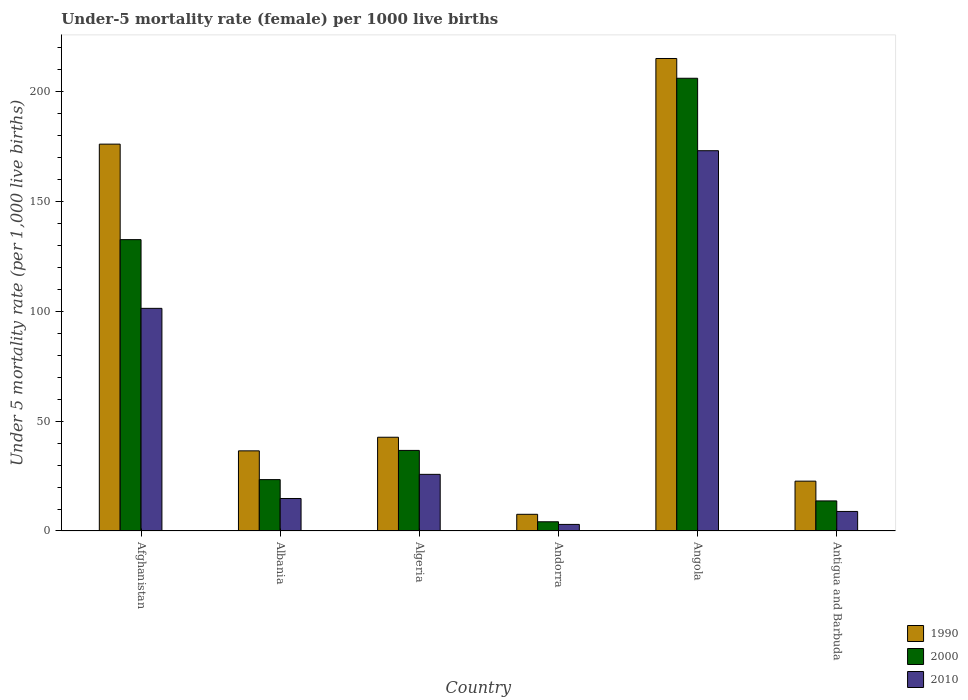How many groups of bars are there?
Keep it short and to the point. 6. Are the number of bars per tick equal to the number of legend labels?
Provide a short and direct response. Yes. Are the number of bars on each tick of the X-axis equal?
Your answer should be very brief. Yes. How many bars are there on the 4th tick from the left?
Ensure brevity in your answer.  3. How many bars are there on the 3rd tick from the right?
Your answer should be very brief. 3. What is the label of the 4th group of bars from the left?
Make the answer very short. Andorra. In how many cases, is the number of bars for a given country not equal to the number of legend labels?
Offer a very short reply. 0. What is the under-five mortality rate in 1990 in Angola?
Provide a short and direct response. 215.2. Across all countries, what is the maximum under-five mortality rate in 2010?
Provide a short and direct response. 173.2. In which country was the under-five mortality rate in 2010 maximum?
Make the answer very short. Angola. In which country was the under-five mortality rate in 2000 minimum?
Provide a short and direct response. Andorra. What is the total under-five mortality rate in 1990 in the graph?
Ensure brevity in your answer.  500.9. What is the difference between the under-five mortality rate in 1990 in Angola and that in Antigua and Barbuda?
Offer a very short reply. 192.5. What is the difference between the under-five mortality rate in 1990 in Algeria and the under-five mortality rate in 2010 in Albania?
Offer a terse response. 27.9. What is the average under-five mortality rate in 1990 per country?
Offer a very short reply. 83.48. What is the difference between the under-five mortality rate of/in 2010 and under-five mortality rate of/in 1990 in Albania?
Ensure brevity in your answer.  -21.7. What is the ratio of the under-five mortality rate in 2000 in Albania to that in Angola?
Your answer should be very brief. 0.11. What is the difference between the highest and the second highest under-five mortality rate in 2010?
Provide a succinct answer. -75.6. What is the difference between the highest and the lowest under-five mortality rate in 2000?
Ensure brevity in your answer.  202. Does the graph contain any zero values?
Make the answer very short. No. Where does the legend appear in the graph?
Ensure brevity in your answer.  Bottom right. How are the legend labels stacked?
Your answer should be very brief. Vertical. What is the title of the graph?
Make the answer very short. Under-5 mortality rate (female) per 1000 live births. Does "2011" appear as one of the legend labels in the graph?
Your answer should be compact. No. What is the label or title of the Y-axis?
Your answer should be compact. Under 5 mortality rate (per 1,0 live births). What is the Under 5 mortality rate (per 1,000 live births) of 1990 in Afghanistan?
Your answer should be very brief. 176.2. What is the Under 5 mortality rate (per 1,000 live births) in 2000 in Afghanistan?
Keep it short and to the point. 132.7. What is the Under 5 mortality rate (per 1,000 live births) in 2010 in Afghanistan?
Keep it short and to the point. 101.4. What is the Under 5 mortality rate (per 1,000 live births) of 1990 in Albania?
Keep it short and to the point. 36.5. What is the Under 5 mortality rate (per 1,000 live births) in 2000 in Albania?
Make the answer very short. 23.4. What is the Under 5 mortality rate (per 1,000 live births) of 1990 in Algeria?
Your answer should be compact. 42.7. What is the Under 5 mortality rate (per 1,000 live births) of 2000 in Algeria?
Provide a short and direct response. 36.7. What is the Under 5 mortality rate (per 1,000 live births) of 2010 in Algeria?
Provide a short and direct response. 25.8. What is the Under 5 mortality rate (per 1,000 live births) of 1990 in Andorra?
Provide a succinct answer. 7.6. What is the Under 5 mortality rate (per 1,000 live births) in 1990 in Angola?
Keep it short and to the point. 215.2. What is the Under 5 mortality rate (per 1,000 live births) in 2000 in Angola?
Make the answer very short. 206.2. What is the Under 5 mortality rate (per 1,000 live births) of 2010 in Angola?
Give a very brief answer. 173.2. What is the Under 5 mortality rate (per 1,000 live births) of 1990 in Antigua and Barbuda?
Provide a succinct answer. 22.7. What is the Under 5 mortality rate (per 1,000 live births) in 2000 in Antigua and Barbuda?
Offer a terse response. 13.7. What is the Under 5 mortality rate (per 1,000 live births) of 2010 in Antigua and Barbuda?
Your response must be concise. 8.9. Across all countries, what is the maximum Under 5 mortality rate (per 1,000 live births) in 1990?
Your response must be concise. 215.2. Across all countries, what is the maximum Under 5 mortality rate (per 1,000 live births) of 2000?
Offer a very short reply. 206.2. Across all countries, what is the maximum Under 5 mortality rate (per 1,000 live births) of 2010?
Your answer should be compact. 173.2. What is the total Under 5 mortality rate (per 1,000 live births) of 1990 in the graph?
Offer a very short reply. 500.9. What is the total Under 5 mortality rate (per 1,000 live births) in 2000 in the graph?
Offer a very short reply. 416.9. What is the total Under 5 mortality rate (per 1,000 live births) of 2010 in the graph?
Your response must be concise. 327.1. What is the difference between the Under 5 mortality rate (per 1,000 live births) of 1990 in Afghanistan and that in Albania?
Your answer should be compact. 139.7. What is the difference between the Under 5 mortality rate (per 1,000 live births) of 2000 in Afghanistan and that in Albania?
Offer a very short reply. 109.3. What is the difference between the Under 5 mortality rate (per 1,000 live births) in 2010 in Afghanistan and that in Albania?
Your answer should be very brief. 86.6. What is the difference between the Under 5 mortality rate (per 1,000 live births) of 1990 in Afghanistan and that in Algeria?
Keep it short and to the point. 133.5. What is the difference between the Under 5 mortality rate (per 1,000 live births) in 2000 in Afghanistan and that in Algeria?
Ensure brevity in your answer.  96. What is the difference between the Under 5 mortality rate (per 1,000 live births) of 2010 in Afghanistan and that in Algeria?
Keep it short and to the point. 75.6. What is the difference between the Under 5 mortality rate (per 1,000 live births) of 1990 in Afghanistan and that in Andorra?
Your response must be concise. 168.6. What is the difference between the Under 5 mortality rate (per 1,000 live births) of 2000 in Afghanistan and that in Andorra?
Give a very brief answer. 128.5. What is the difference between the Under 5 mortality rate (per 1,000 live births) in 2010 in Afghanistan and that in Andorra?
Offer a very short reply. 98.4. What is the difference between the Under 5 mortality rate (per 1,000 live births) of 1990 in Afghanistan and that in Angola?
Offer a very short reply. -39. What is the difference between the Under 5 mortality rate (per 1,000 live births) of 2000 in Afghanistan and that in Angola?
Offer a very short reply. -73.5. What is the difference between the Under 5 mortality rate (per 1,000 live births) in 2010 in Afghanistan and that in Angola?
Offer a very short reply. -71.8. What is the difference between the Under 5 mortality rate (per 1,000 live births) in 1990 in Afghanistan and that in Antigua and Barbuda?
Make the answer very short. 153.5. What is the difference between the Under 5 mortality rate (per 1,000 live births) in 2000 in Afghanistan and that in Antigua and Barbuda?
Provide a succinct answer. 119. What is the difference between the Under 5 mortality rate (per 1,000 live births) of 2010 in Afghanistan and that in Antigua and Barbuda?
Provide a short and direct response. 92.5. What is the difference between the Under 5 mortality rate (per 1,000 live births) of 2000 in Albania and that in Algeria?
Offer a very short reply. -13.3. What is the difference between the Under 5 mortality rate (per 1,000 live births) in 2010 in Albania and that in Algeria?
Make the answer very short. -11. What is the difference between the Under 5 mortality rate (per 1,000 live births) of 1990 in Albania and that in Andorra?
Offer a terse response. 28.9. What is the difference between the Under 5 mortality rate (per 1,000 live births) in 2000 in Albania and that in Andorra?
Offer a very short reply. 19.2. What is the difference between the Under 5 mortality rate (per 1,000 live births) of 2010 in Albania and that in Andorra?
Offer a terse response. 11.8. What is the difference between the Under 5 mortality rate (per 1,000 live births) in 1990 in Albania and that in Angola?
Your answer should be compact. -178.7. What is the difference between the Under 5 mortality rate (per 1,000 live births) in 2000 in Albania and that in Angola?
Your answer should be very brief. -182.8. What is the difference between the Under 5 mortality rate (per 1,000 live births) in 2010 in Albania and that in Angola?
Keep it short and to the point. -158.4. What is the difference between the Under 5 mortality rate (per 1,000 live births) in 1990 in Albania and that in Antigua and Barbuda?
Ensure brevity in your answer.  13.8. What is the difference between the Under 5 mortality rate (per 1,000 live births) of 2000 in Albania and that in Antigua and Barbuda?
Your response must be concise. 9.7. What is the difference between the Under 5 mortality rate (per 1,000 live births) of 1990 in Algeria and that in Andorra?
Your answer should be compact. 35.1. What is the difference between the Under 5 mortality rate (per 1,000 live births) in 2000 in Algeria and that in Andorra?
Keep it short and to the point. 32.5. What is the difference between the Under 5 mortality rate (per 1,000 live births) of 2010 in Algeria and that in Andorra?
Give a very brief answer. 22.8. What is the difference between the Under 5 mortality rate (per 1,000 live births) in 1990 in Algeria and that in Angola?
Provide a short and direct response. -172.5. What is the difference between the Under 5 mortality rate (per 1,000 live births) of 2000 in Algeria and that in Angola?
Your answer should be very brief. -169.5. What is the difference between the Under 5 mortality rate (per 1,000 live births) in 2010 in Algeria and that in Angola?
Your answer should be compact. -147.4. What is the difference between the Under 5 mortality rate (per 1,000 live births) of 1990 in Andorra and that in Angola?
Make the answer very short. -207.6. What is the difference between the Under 5 mortality rate (per 1,000 live births) in 2000 in Andorra and that in Angola?
Give a very brief answer. -202. What is the difference between the Under 5 mortality rate (per 1,000 live births) in 2010 in Andorra and that in Angola?
Your response must be concise. -170.2. What is the difference between the Under 5 mortality rate (per 1,000 live births) of 1990 in Andorra and that in Antigua and Barbuda?
Provide a short and direct response. -15.1. What is the difference between the Under 5 mortality rate (per 1,000 live births) in 2010 in Andorra and that in Antigua and Barbuda?
Provide a succinct answer. -5.9. What is the difference between the Under 5 mortality rate (per 1,000 live births) of 1990 in Angola and that in Antigua and Barbuda?
Make the answer very short. 192.5. What is the difference between the Under 5 mortality rate (per 1,000 live births) of 2000 in Angola and that in Antigua and Barbuda?
Offer a terse response. 192.5. What is the difference between the Under 5 mortality rate (per 1,000 live births) in 2010 in Angola and that in Antigua and Barbuda?
Make the answer very short. 164.3. What is the difference between the Under 5 mortality rate (per 1,000 live births) in 1990 in Afghanistan and the Under 5 mortality rate (per 1,000 live births) in 2000 in Albania?
Give a very brief answer. 152.8. What is the difference between the Under 5 mortality rate (per 1,000 live births) in 1990 in Afghanistan and the Under 5 mortality rate (per 1,000 live births) in 2010 in Albania?
Provide a succinct answer. 161.4. What is the difference between the Under 5 mortality rate (per 1,000 live births) of 2000 in Afghanistan and the Under 5 mortality rate (per 1,000 live births) of 2010 in Albania?
Your response must be concise. 117.9. What is the difference between the Under 5 mortality rate (per 1,000 live births) of 1990 in Afghanistan and the Under 5 mortality rate (per 1,000 live births) of 2000 in Algeria?
Give a very brief answer. 139.5. What is the difference between the Under 5 mortality rate (per 1,000 live births) in 1990 in Afghanistan and the Under 5 mortality rate (per 1,000 live births) in 2010 in Algeria?
Your answer should be compact. 150.4. What is the difference between the Under 5 mortality rate (per 1,000 live births) in 2000 in Afghanistan and the Under 5 mortality rate (per 1,000 live births) in 2010 in Algeria?
Offer a terse response. 106.9. What is the difference between the Under 5 mortality rate (per 1,000 live births) of 1990 in Afghanistan and the Under 5 mortality rate (per 1,000 live births) of 2000 in Andorra?
Offer a very short reply. 172. What is the difference between the Under 5 mortality rate (per 1,000 live births) of 1990 in Afghanistan and the Under 5 mortality rate (per 1,000 live births) of 2010 in Andorra?
Make the answer very short. 173.2. What is the difference between the Under 5 mortality rate (per 1,000 live births) of 2000 in Afghanistan and the Under 5 mortality rate (per 1,000 live births) of 2010 in Andorra?
Your answer should be compact. 129.7. What is the difference between the Under 5 mortality rate (per 1,000 live births) of 2000 in Afghanistan and the Under 5 mortality rate (per 1,000 live births) of 2010 in Angola?
Offer a terse response. -40.5. What is the difference between the Under 5 mortality rate (per 1,000 live births) in 1990 in Afghanistan and the Under 5 mortality rate (per 1,000 live births) in 2000 in Antigua and Barbuda?
Keep it short and to the point. 162.5. What is the difference between the Under 5 mortality rate (per 1,000 live births) of 1990 in Afghanistan and the Under 5 mortality rate (per 1,000 live births) of 2010 in Antigua and Barbuda?
Keep it short and to the point. 167.3. What is the difference between the Under 5 mortality rate (per 1,000 live births) in 2000 in Afghanistan and the Under 5 mortality rate (per 1,000 live births) in 2010 in Antigua and Barbuda?
Your answer should be compact. 123.8. What is the difference between the Under 5 mortality rate (per 1,000 live births) of 1990 in Albania and the Under 5 mortality rate (per 1,000 live births) of 2000 in Algeria?
Ensure brevity in your answer.  -0.2. What is the difference between the Under 5 mortality rate (per 1,000 live births) of 1990 in Albania and the Under 5 mortality rate (per 1,000 live births) of 2010 in Algeria?
Make the answer very short. 10.7. What is the difference between the Under 5 mortality rate (per 1,000 live births) of 1990 in Albania and the Under 5 mortality rate (per 1,000 live births) of 2000 in Andorra?
Keep it short and to the point. 32.3. What is the difference between the Under 5 mortality rate (per 1,000 live births) in 1990 in Albania and the Under 5 mortality rate (per 1,000 live births) in 2010 in Andorra?
Make the answer very short. 33.5. What is the difference between the Under 5 mortality rate (per 1,000 live births) of 2000 in Albania and the Under 5 mortality rate (per 1,000 live births) of 2010 in Andorra?
Ensure brevity in your answer.  20.4. What is the difference between the Under 5 mortality rate (per 1,000 live births) of 1990 in Albania and the Under 5 mortality rate (per 1,000 live births) of 2000 in Angola?
Give a very brief answer. -169.7. What is the difference between the Under 5 mortality rate (per 1,000 live births) of 1990 in Albania and the Under 5 mortality rate (per 1,000 live births) of 2010 in Angola?
Your answer should be very brief. -136.7. What is the difference between the Under 5 mortality rate (per 1,000 live births) of 2000 in Albania and the Under 5 mortality rate (per 1,000 live births) of 2010 in Angola?
Offer a terse response. -149.8. What is the difference between the Under 5 mortality rate (per 1,000 live births) of 1990 in Albania and the Under 5 mortality rate (per 1,000 live births) of 2000 in Antigua and Barbuda?
Your response must be concise. 22.8. What is the difference between the Under 5 mortality rate (per 1,000 live births) in 1990 in Albania and the Under 5 mortality rate (per 1,000 live births) in 2010 in Antigua and Barbuda?
Provide a succinct answer. 27.6. What is the difference between the Under 5 mortality rate (per 1,000 live births) of 2000 in Albania and the Under 5 mortality rate (per 1,000 live births) of 2010 in Antigua and Barbuda?
Offer a terse response. 14.5. What is the difference between the Under 5 mortality rate (per 1,000 live births) in 1990 in Algeria and the Under 5 mortality rate (per 1,000 live births) in 2000 in Andorra?
Your answer should be very brief. 38.5. What is the difference between the Under 5 mortality rate (per 1,000 live births) in 1990 in Algeria and the Under 5 mortality rate (per 1,000 live births) in 2010 in Andorra?
Make the answer very short. 39.7. What is the difference between the Under 5 mortality rate (per 1,000 live births) of 2000 in Algeria and the Under 5 mortality rate (per 1,000 live births) of 2010 in Andorra?
Offer a very short reply. 33.7. What is the difference between the Under 5 mortality rate (per 1,000 live births) in 1990 in Algeria and the Under 5 mortality rate (per 1,000 live births) in 2000 in Angola?
Your answer should be very brief. -163.5. What is the difference between the Under 5 mortality rate (per 1,000 live births) of 1990 in Algeria and the Under 5 mortality rate (per 1,000 live births) of 2010 in Angola?
Offer a terse response. -130.5. What is the difference between the Under 5 mortality rate (per 1,000 live births) of 2000 in Algeria and the Under 5 mortality rate (per 1,000 live births) of 2010 in Angola?
Provide a succinct answer. -136.5. What is the difference between the Under 5 mortality rate (per 1,000 live births) in 1990 in Algeria and the Under 5 mortality rate (per 1,000 live births) in 2000 in Antigua and Barbuda?
Give a very brief answer. 29. What is the difference between the Under 5 mortality rate (per 1,000 live births) of 1990 in Algeria and the Under 5 mortality rate (per 1,000 live births) of 2010 in Antigua and Barbuda?
Offer a very short reply. 33.8. What is the difference between the Under 5 mortality rate (per 1,000 live births) of 2000 in Algeria and the Under 5 mortality rate (per 1,000 live births) of 2010 in Antigua and Barbuda?
Your answer should be very brief. 27.8. What is the difference between the Under 5 mortality rate (per 1,000 live births) of 1990 in Andorra and the Under 5 mortality rate (per 1,000 live births) of 2000 in Angola?
Keep it short and to the point. -198.6. What is the difference between the Under 5 mortality rate (per 1,000 live births) of 1990 in Andorra and the Under 5 mortality rate (per 1,000 live births) of 2010 in Angola?
Provide a succinct answer. -165.6. What is the difference between the Under 5 mortality rate (per 1,000 live births) of 2000 in Andorra and the Under 5 mortality rate (per 1,000 live births) of 2010 in Angola?
Offer a very short reply. -169. What is the difference between the Under 5 mortality rate (per 1,000 live births) in 1990 in Andorra and the Under 5 mortality rate (per 1,000 live births) in 2010 in Antigua and Barbuda?
Provide a short and direct response. -1.3. What is the difference between the Under 5 mortality rate (per 1,000 live births) of 2000 in Andorra and the Under 5 mortality rate (per 1,000 live births) of 2010 in Antigua and Barbuda?
Provide a succinct answer. -4.7. What is the difference between the Under 5 mortality rate (per 1,000 live births) in 1990 in Angola and the Under 5 mortality rate (per 1,000 live births) in 2000 in Antigua and Barbuda?
Offer a very short reply. 201.5. What is the difference between the Under 5 mortality rate (per 1,000 live births) in 1990 in Angola and the Under 5 mortality rate (per 1,000 live births) in 2010 in Antigua and Barbuda?
Keep it short and to the point. 206.3. What is the difference between the Under 5 mortality rate (per 1,000 live births) in 2000 in Angola and the Under 5 mortality rate (per 1,000 live births) in 2010 in Antigua and Barbuda?
Make the answer very short. 197.3. What is the average Under 5 mortality rate (per 1,000 live births) in 1990 per country?
Provide a short and direct response. 83.48. What is the average Under 5 mortality rate (per 1,000 live births) of 2000 per country?
Make the answer very short. 69.48. What is the average Under 5 mortality rate (per 1,000 live births) of 2010 per country?
Offer a very short reply. 54.52. What is the difference between the Under 5 mortality rate (per 1,000 live births) of 1990 and Under 5 mortality rate (per 1,000 live births) of 2000 in Afghanistan?
Keep it short and to the point. 43.5. What is the difference between the Under 5 mortality rate (per 1,000 live births) of 1990 and Under 5 mortality rate (per 1,000 live births) of 2010 in Afghanistan?
Make the answer very short. 74.8. What is the difference between the Under 5 mortality rate (per 1,000 live births) of 2000 and Under 5 mortality rate (per 1,000 live births) of 2010 in Afghanistan?
Offer a very short reply. 31.3. What is the difference between the Under 5 mortality rate (per 1,000 live births) in 1990 and Under 5 mortality rate (per 1,000 live births) in 2000 in Albania?
Your response must be concise. 13.1. What is the difference between the Under 5 mortality rate (per 1,000 live births) of 1990 and Under 5 mortality rate (per 1,000 live births) of 2010 in Albania?
Offer a very short reply. 21.7. What is the difference between the Under 5 mortality rate (per 1,000 live births) in 1990 and Under 5 mortality rate (per 1,000 live births) in 2010 in Algeria?
Provide a succinct answer. 16.9. What is the difference between the Under 5 mortality rate (per 1,000 live births) of 1990 and Under 5 mortality rate (per 1,000 live births) of 2010 in Andorra?
Ensure brevity in your answer.  4.6. What is the ratio of the Under 5 mortality rate (per 1,000 live births) of 1990 in Afghanistan to that in Albania?
Make the answer very short. 4.83. What is the ratio of the Under 5 mortality rate (per 1,000 live births) of 2000 in Afghanistan to that in Albania?
Your answer should be very brief. 5.67. What is the ratio of the Under 5 mortality rate (per 1,000 live births) of 2010 in Afghanistan to that in Albania?
Ensure brevity in your answer.  6.85. What is the ratio of the Under 5 mortality rate (per 1,000 live births) in 1990 in Afghanistan to that in Algeria?
Your answer should be compact. 4.13. What is the ratio of the Under 5 mortality rate (per 1,000 live births) in 2000 in Afghanistan to that in Algeria?
Make the answer very short. 3.62. What is the ratio of the Under 5 mortality rate (per 1,000 live births) in 2010 in Afghanistan to that in Algeria?
Your answer should be very brief. 3.93. What is the ratio of the Under 5 mortality rate (per 1,000 live births) in 1990 in Afghanistan to that in Andorra?
Your answer should be compact. 23.18. What is the ratio of the Under 5 mortality rate (per 1,000 live births) in 2000 in Afghanistan to that in Andorra?
Provide a succinct answer. 31.6. What is the ratio of the Under 5 mortality rate (per 1,000 live births) in 2010 in Afghanistan to that in Andorra?
Your response must be concise. 33.8. What is the ratio of the Under 5 mortality rate (per 1,000 live births) in 1990 in Afghanistan to that in Angola?
Provide a short and direct response. 0.82. What is the ratio of the Under 5 mortality rate (per 1,000 live births) in 2000 in Afghanistan to that in Angola?
Your response must be concise. 0.64. What is the ratio of the Under 5 mortality rate (per 1,000 live births) of 2010 in Afghanistan to that in Angola?
Offer a very short reply. 0.59. What is the ratio of the Under 5 mortality rate (per 1,000 live births) of 1990 in Afghanistan to that in Antigua and Barbuda?
Provide a short and direct response. 7.76. What is the ratio of the Under 5 mortality rate (per 1,000 live births) in 2000 in Afghanistan to that in Antigua and Barbuda?
Give a very brief answer. 9.69. What is the ratio of the Under 5 mortality rate (per 1,000 live births) in 2010 in Afghanistan to that in Antigua and Barbuda?
Your answer should be very brief. 11.39. What is the ratio of the Under 5 mortality rate (per 1,000 live births) in 1990 in Albania to that in Algeria?
Provide a short and direct response. 0.85. What is the ratio of the Under 5 mortality rate (per 1,000 live births) in 2000 in Albania to that in Algeria?
Your answer should be very brief. 0.64. What is the ratio of the Under 5 mortality rate (per 1,000 live births) in 2010 in Albania to that in Algeria?
Your answer should be compact. 0.57. What is the ratio of the Under 5 mortality rate (per 1,000 live births) of 1990 in Albania to that in Andorra?
Make the answer very short. 4.8. What is the ratio of the Under 5 mortality rate (per 1,000 live births) of 2000 in Albania to that in Andorra?
Ensure brevity in your answer.  5.57. What is the ratio of the Under 5 mortality rate (per 1,000 live births) in 2010 in Albania to that in Andorra?
Your answer should be compact. 4.93. What is the ratio of the Under 5 mortality rate (per 1,000 live births) of 1990 in Albania to that in Angola?
Offer a very short reply. 0.17. What is the ratio of the Under 5 mortality rate (per 1,000 live births) of 2000 in Albania to that in Angola?
Offer a very short reply. 0.11. What is the ratio of the Under 5 mortality rate (per 1,000 live births) of 2010 in Albania to that in Angola?
Make the answer very short. 0.09. What is the ratio of the Under 5 mortality rate (per 1,000 live births) of 1990 in Albania to that in Antigua and Barbuda?
Provide a succinct answer. 1.61. What is the ratio of the Under 5 mortality rate (per 1,000 live births) of 2000 in Albania to that in Antigua and Barbuda?
Provide a succinct answer. 1.71. What is the ratio of the Under 5 mortality rate (per 1,000 live births) in 2010 in Albania to that in Antigua and Barbuda?
Ensure brevity in your answer.  1.66. What is the ratio of the Under 5 mortality rate (per 1,000 live births) in 1990 in Algeria to that in Andorra?
Your answer should be compact. 5.62. What is the ratio of the Under 5 mortality rate (per 1,000 live births) of 2000 in Algeria to that in Andorra?
Provide a succinct answer. 8.74. What is the ratio of the Under 5 mortality rate (per 1,000 live births) of 1990 in Algeria to that in Angola?
Your answer should be compact. 0.2. What is the ratio of the Under 5 mortality rate (per 1,000 live births) of 2000 in Algeria to that in Angola?
Offer a very short reply. 0.18. What is the ratio of the Under 5 mortality rate (per 1,000 live births) in 2010 in Algeria to that in Angola?
Keep it short and to the point. 0.15. What is the ratio of the Under 5 mortality rate (per 1,000 live births) of 1990 in Algeria to that in Antigua and Barbuda?
Offer a very short reply. 1.88. What is the ratio of the Under 5 mortality rate (per 1,000 live births) in 2000 in Algeria to that in Antigua and Barbuda?
Keep it short and to the point. 2.68. What is the ratio of the Under 5 mortality rate (per 1,000 live births) of 2010 in Algeria to that in Antigua and Barbuda?
Give a very brief answer. 2.9. What is the ratio of the Under 5 mortality rate (per 1,000 live births) in 1990 in Andorra to that in Angola?
Offer a very short reply. 0.04. What is the ratio of the Under 5 mortality rate (per 1,000 live births) of 2000 in Andorra to that in Angola?
Ensure brevity in your answer.  0.02. What is the ratio of the Under 5 mortality rate (per 1,000 live births) of 2010 in Andorra to that in Angola?
Your answer should be compact. 0.02. What is the ratio of the Under 5 mortality rate (per 1,000 live births) in 1990 in Andorra to that in Antigua and Barbuda?
Give a very brief answer. 0.33. What is the ratio of the Under 5 mortality rate (per 1,000 live births) of 2000 in Andorra to that in Antigua and Barbuda?
Give a very brief answer. 0.31. What is the ratio of the Under 5 mortality rate (per 1,000 live births) in 2010 in Andorra to that in Antigua and Barbuda?
Make the answer very short. 0.34. What is the ratio of the Under 5 mortality rate (per 1,000 live births) of 1990 in Angola to that in Antigua and Barbuda?
Keep it short and to the point. 9.48. What is the ratio of the Under 5 mortality rate (per 1,000 live births) of 2000 in Angola to that in Antigua and Barbuda?
Make the answer very short. 15.05. What is the ratio of the Under 5 mortality rate (per 1,000 live births) in 2010 in Angola to that in Antigua and Barbuda?
Keep it short and to the point. 19.46. What is the difference between the highest and the second highest Under 5 mortality rate (per 1,000 live births) in 2000?
Keep it short and to the point. 73.5. What is the difference between the highest and the second highest Under 5 mortality rate (per 1,000 live births) of 2010?
Give a very brief answer. 71.8. What is the difference between the highest and the lowest Under 5 mortality rate (per 1,000 live births) in 1990?
Ensure brevity in your answer.  207.6. What is the difference between the highest and the lowest Under 5 mortality rate (per 1,000 live births) of 2000?
Give a very brief answer. 202. What is the difference between the highest and the lowest Under 5 mortality rate (per 1,000 live births) in 2010?
Make the answer very short. 170.2. 